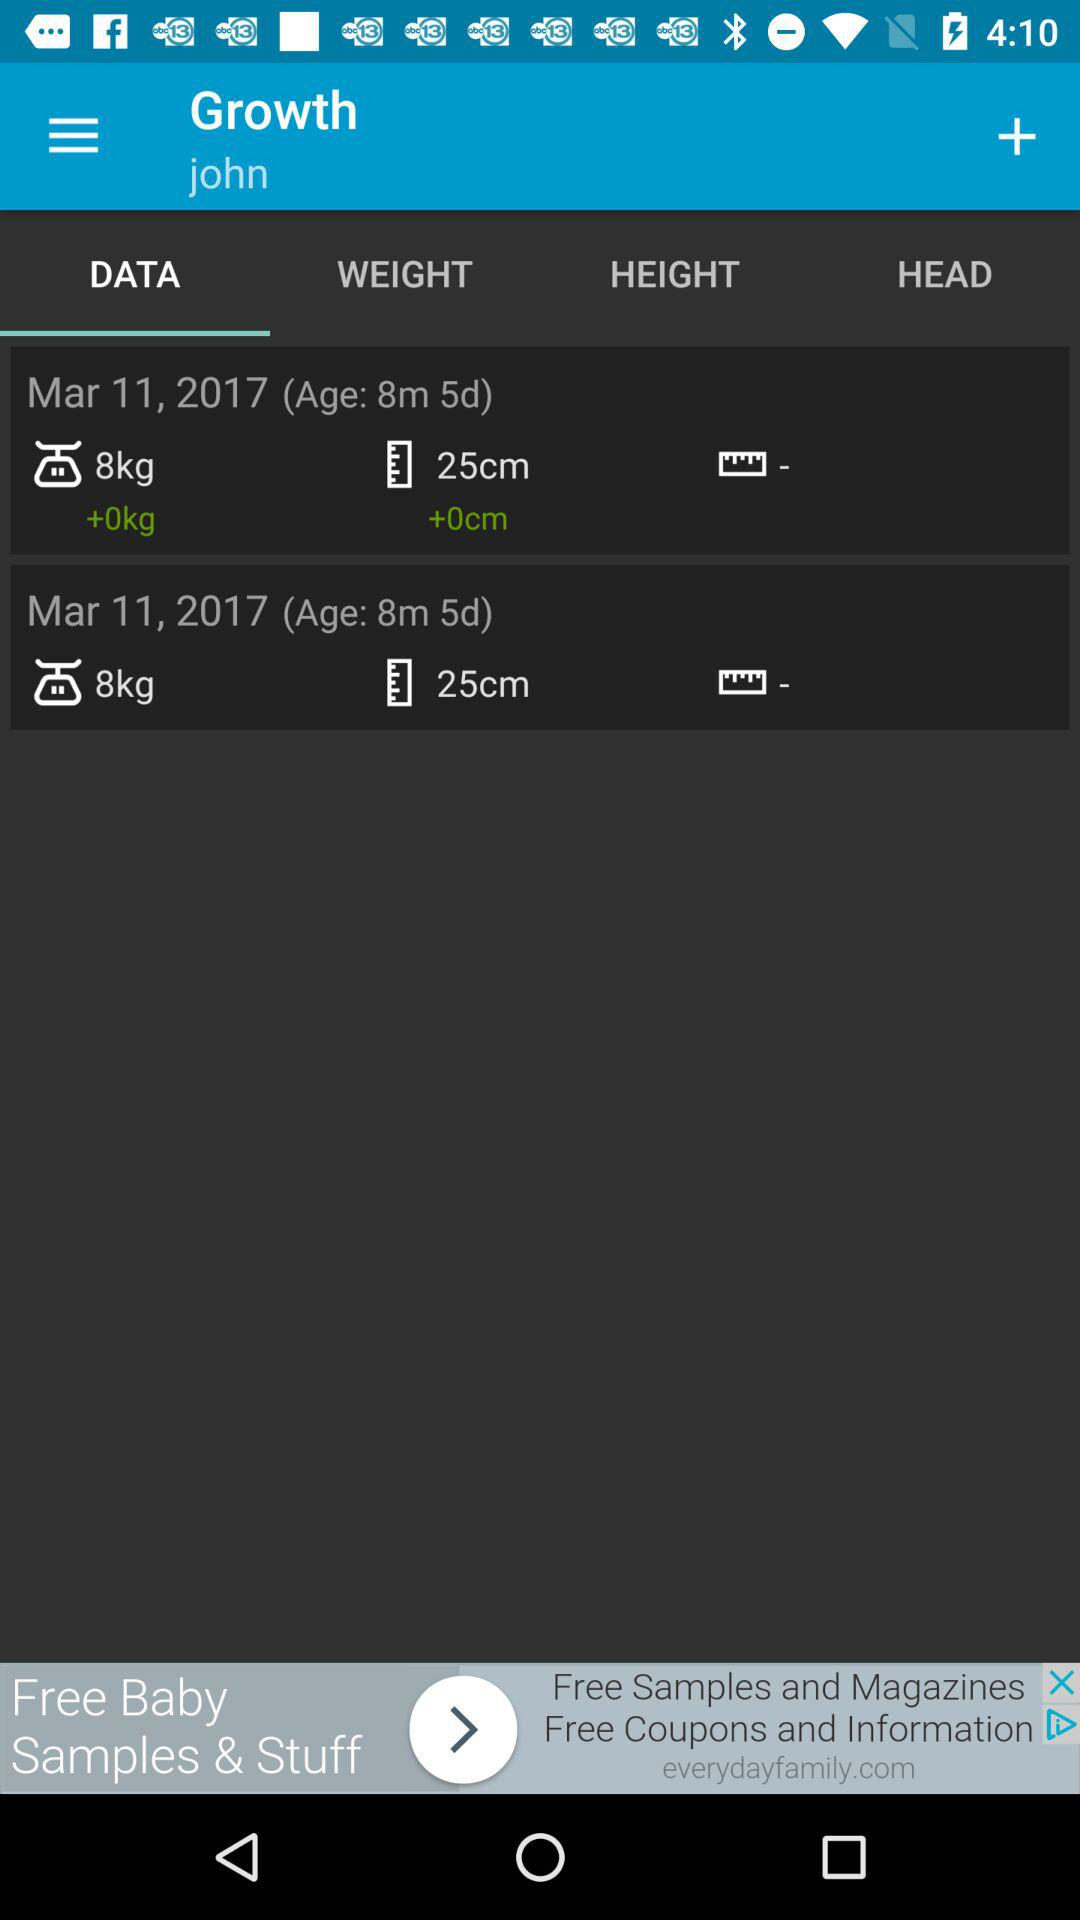What is the user name? The user name is "john". 